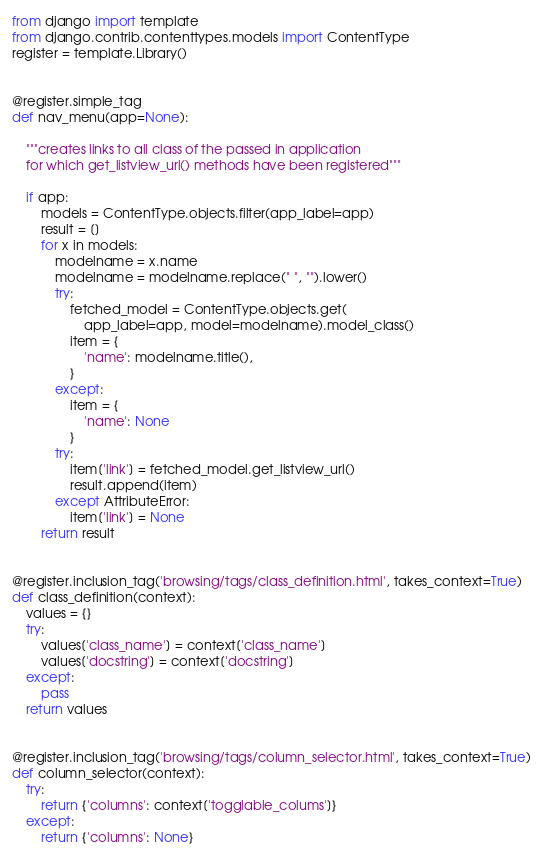<code> <loc_0><loc_0><loc_500><loc_500><_Python_>from django import template
from django.contrib.contenttypes.models import ContentType
register = template.Library()


@register.simple_tag
def nav_menu(app=None):

    """creates links to all class of the passed in application
    for which get_listview_url() methods have been registered"""

    if app:
        models = ContentType.objects.filter(app_label=app)
        result = []
        for x in models:
            modelname = x.name
            modelname = modelname.replace(" ", "").lower()
            try:
                fetched_model = ContentType.objects.get(
                    app_label=app, model=modelname).model_class()
                item = {
                    'name': modelname.title(),
                }
            except:
                item = {
                    'name': None
                }
            try:
                item['link'] = fetched_model.get_listview_url()
                result.append(item)
            except AttributeError:
                item['link'] = None
        return result


@register.inclusion_tag('browsing/tags/class_definition.html', takes_context=True)
def class_definition(context):
    values = {}
    try:
        values['class_name'] = context['class_name']
        values['docstring'] = context['docstring']
    except:
        pass
    return values


@register.inclusion_tag('browsing/tags/column_selector.html', takes_context=True)
def column_selector(context):
    try:
        return {'columns': context['togglable_colums']}
    except:
        return {'columns': None}
</code> 